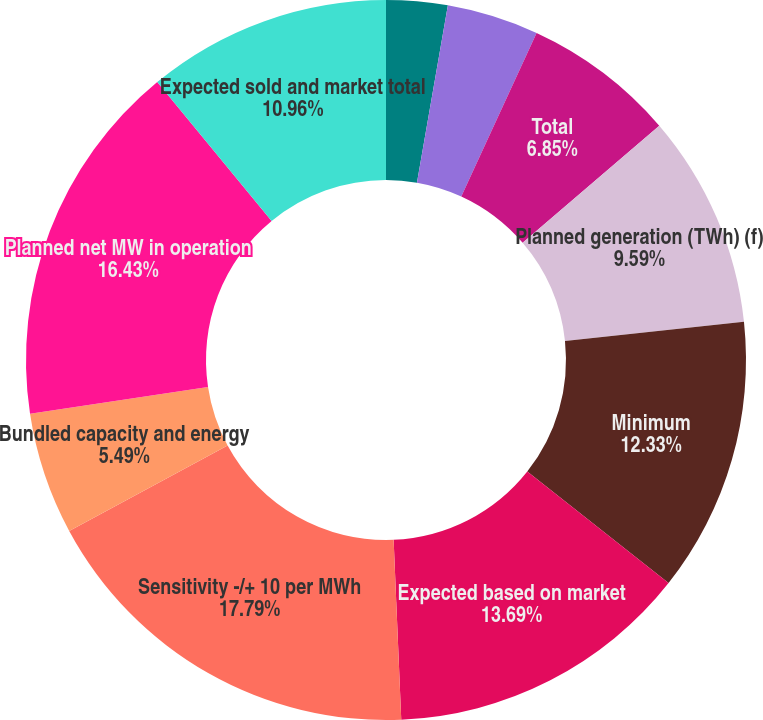Convert chart to OTSL. <chart><loc_0><loc_0><loc_500><loc_500><pie_chart><fcel>Unit-contingent (b)<fcel>Unit-contingent with<fcel>Total<fcel>Planned generation (TWh) (f)<fcel>Minimum<fcel>Expected based on market<fcel>Sensitivity -/+ 10 per MWh<fcel>Bundled capacity and energy<fcel>Planned net MW in operation<fcel>Expected sold and market total<nl><fcel>2.75%<fcel>4.12%<fcel>6.85%<fcel>9.59%<fcel>12.33%<fcel>13.69%<fcel>17.8%<fcel>5.49%<fcel>16.43%<fcel>10.96%<nl></chart> 